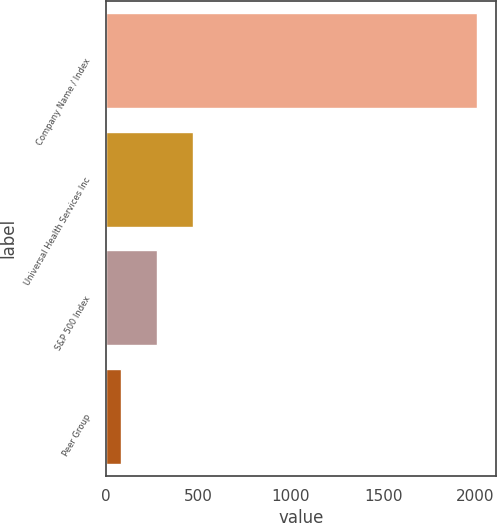Convert chart to OTSL. <chart><loc_0><loc_0><loc_500><loc_500><bar_chart><fcel>Company Name / Index<fcel>Universal Health Services Inc<fcel>S&P 500 Index<fcel>Peer Group<nl><fcel>2011<fcel>468.74<fcel>275.96<fcel>83.18<nl></chart> 